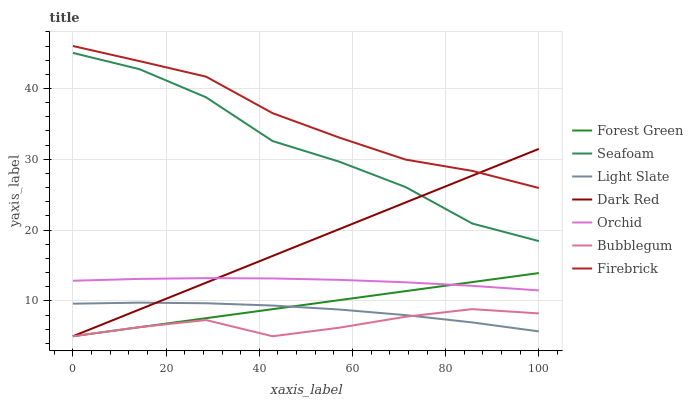Does Bubblegum have the minimum area under the curve?
Answer yes or no. Yes. Does Firebrick have the maximum area under the curve?
Answer yes or no. Yes. Does Dark Red have the minimum area under the curve?
Answer yes or no. No. Does Dark Red have the maximum area under the curve?
Answer yes or no. No. Is Forest Green the smoothest?
Answer yes or no. Yes. Is Seafoam the roughest?
Answer yes or no. Yes. Is Dark Red the smoothest?
Answer yes or no. No. Is Dark Red the roughest?
Answer yes or no. No. Does Dark Red have the lowest value?
Answer yes or no. Yes. Does Firebrick have the lowest value?
Answer yes or no. No. Does Firebrick have the highest value?
Answer yes or no. Yes. Does Dark Red have the highest value?
Answer yes or no. No. Is Light Slate less than Firebrick?
Answer yes or no. Yes. Is Seafoam greater than Orchid?
Answer yes or no. Yes. Does Bubblegum intersect Forest Green?
Answer yes or no. Yes. Is Bubblegum less than Forest Green?
Answer yes or no. No. Is Bubblegum greater than Forest Green?
Answer yes or no. No. Does Light Slate intersect Firebrick?
Answer yes or no. No. 